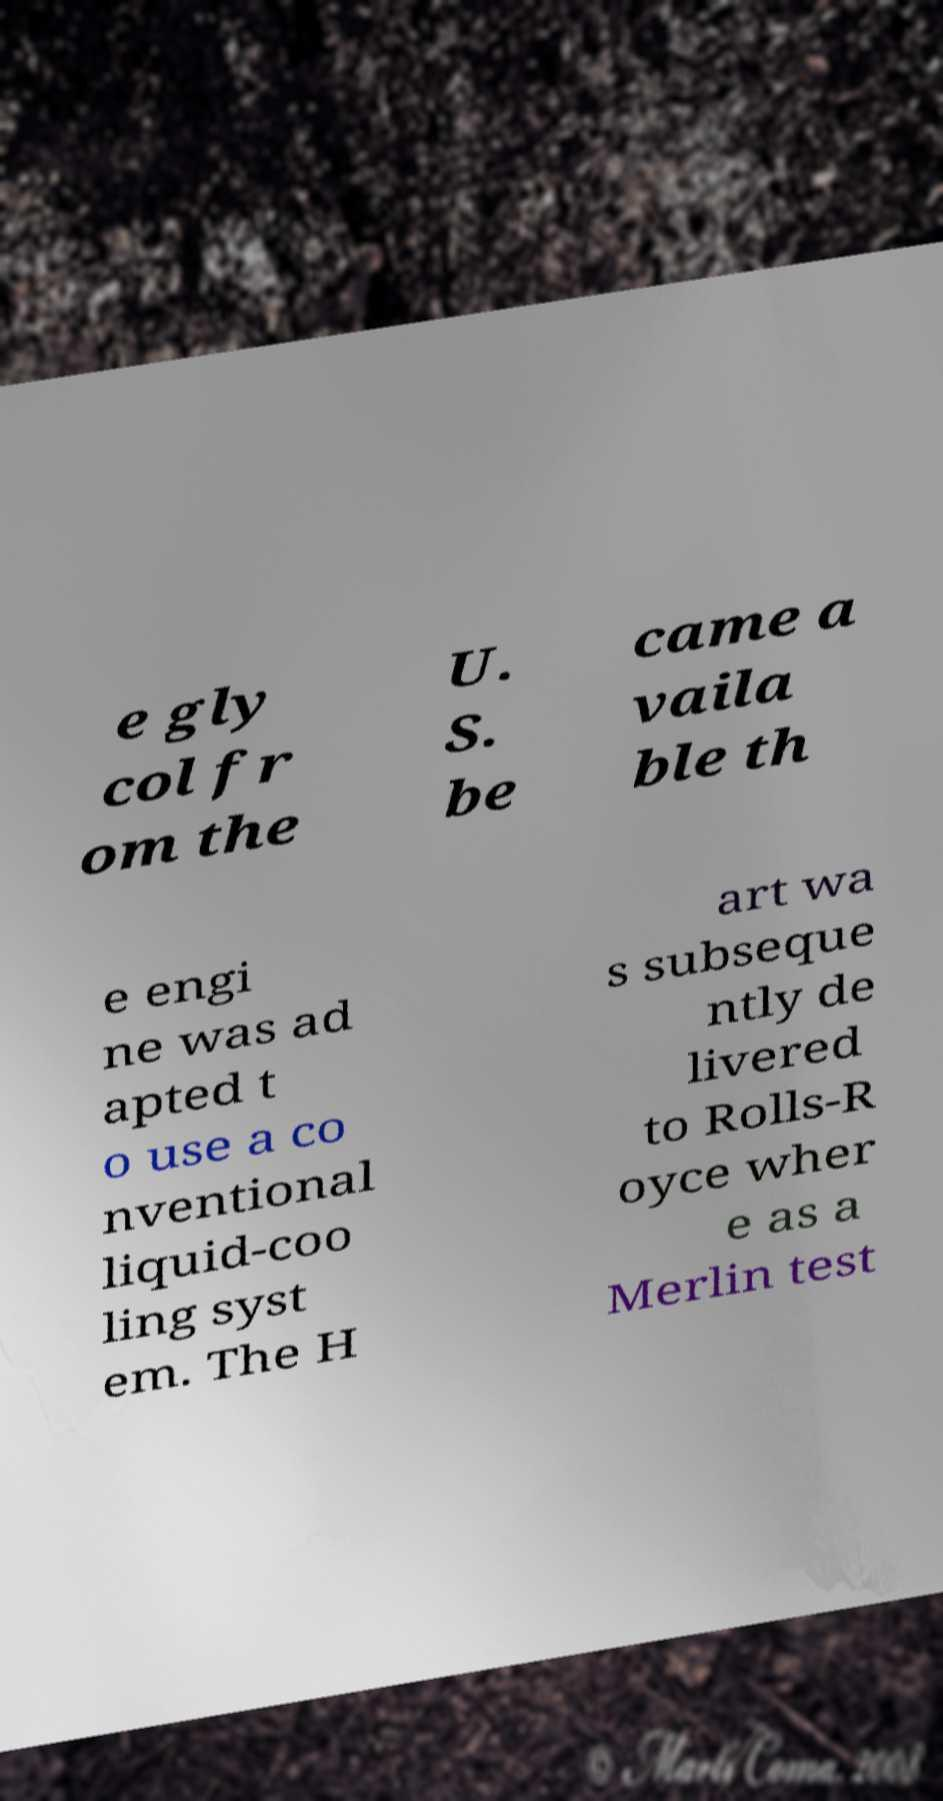Please identify and transcribe the text found in this image. e gly col fr om the U. S. be came a vaila ble th e engi ne was ad apted t o use a co nventional liquid-coo ling syst em. The H art wa s subseque ntly de livered to Rolls-R oyce wher e as a Merlin test 